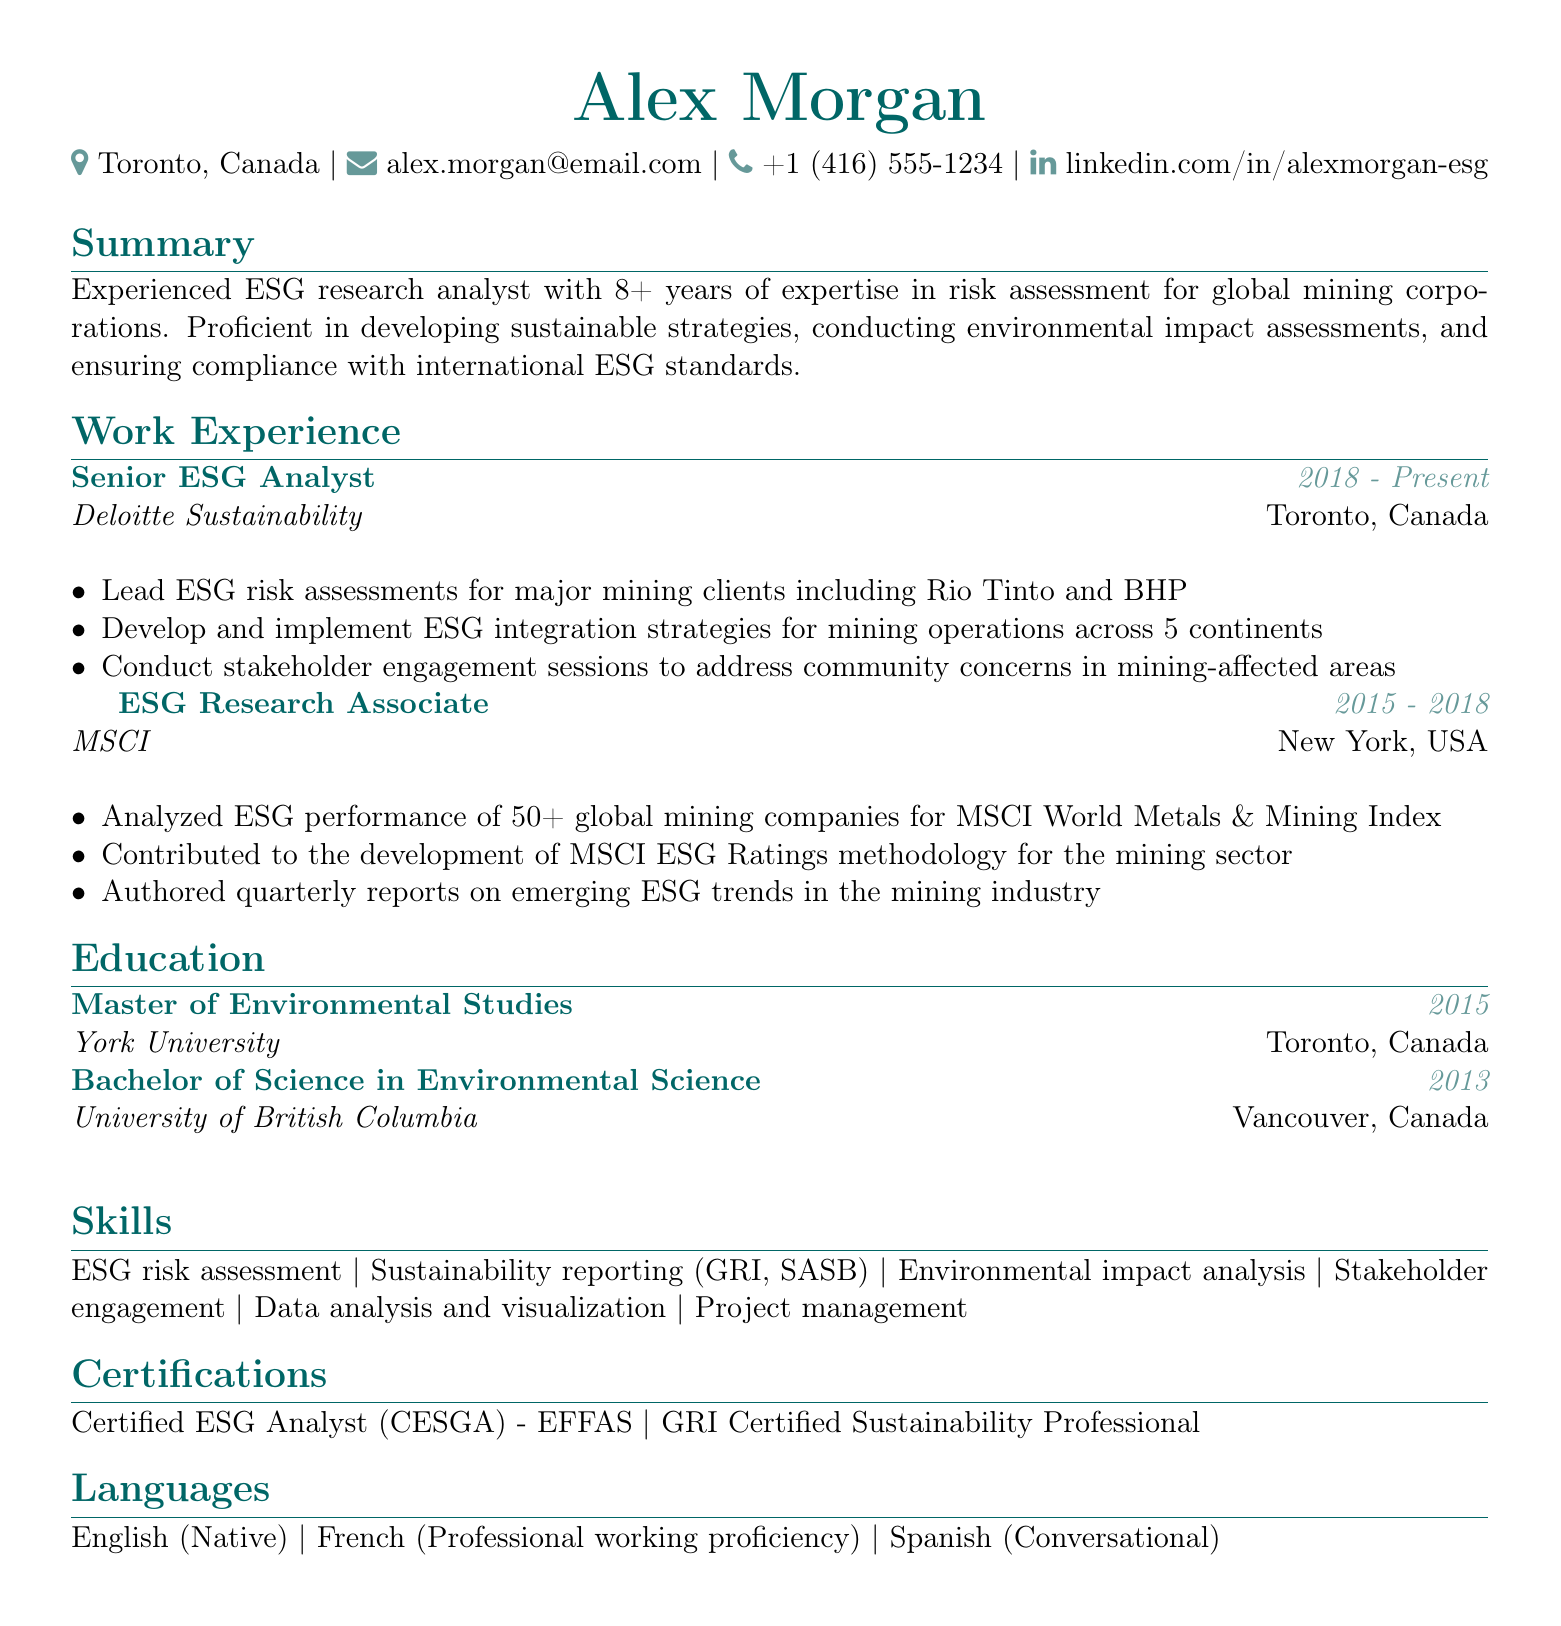What is the name of the candidate? The name is listed in the header of the document, which is Alex Morgan.
Answer: Alex Morgan What is the location of Alex Morgan? The location is specified in the personal information section of the document, which is Toronto, Canada.
Answer: Toronto, Canada How many years of experience does Alex Morgan have in ESG risk assessment? The summary section indicates that Alex has 8+ years of expertise.
Answer: 8+ What is Alex Morgan's current job title? The current job title is found in the work experience section, which is Senior ESG Analyst.
Answer: Senior ESG Analyst Which company did Alex work for before Deloitte Sustainability? The prior company is mentioned in the work experience section, which is MSCI.
Answer: MSCI In what year did Alex complete the Master of Environmental Studies? The education section specifies the completion year as 2015.
Answer: 2015 What are the two certifications listed in the resume? The certifications are found in the certifications section, specifically Certified ESG Analyst (CESGA) and GRI Certified Sustainability Professional.
Answer: Certified ESG Analyst (CESGA) - GRI Certified Sustainability Professional What language does Alex speak at a professional working proficiency level? The languages section indicates that Alex speaks French at a professional working proficiency.
Answer: French How many continents has Alex developed and implemented ESG integration strategies across? The work experience section specifies that strategies were developed across 5 continents.
Answer: 5 continents 